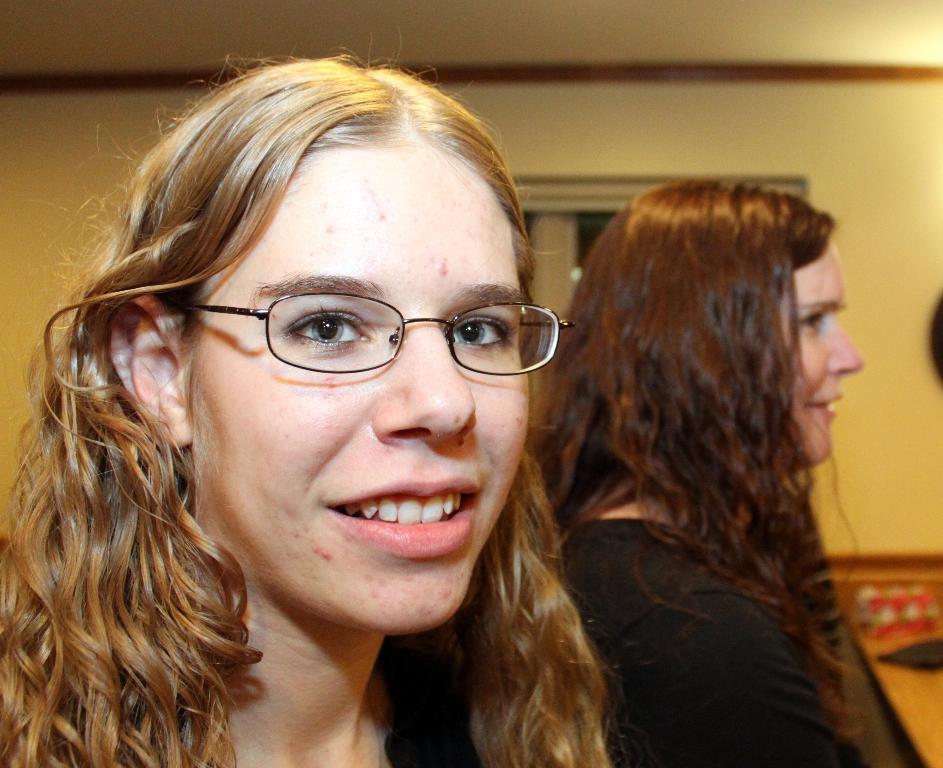Describe this image in one or two sentences. In the picture we can see a woman standing and smiling and she has a gold color, curly hair and behind her we can see another woman standing and she is with a black dress and in the background we can see a wall with a window. 